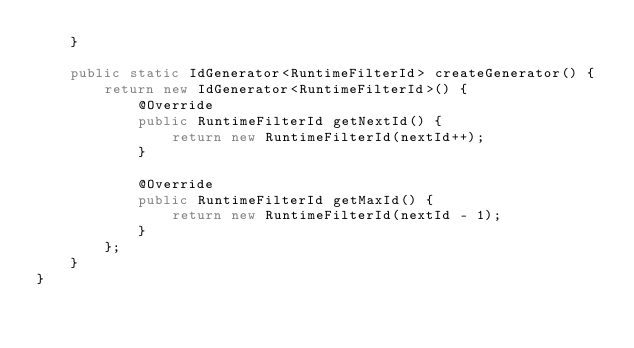<code> <loc_0><loc_0><loc_500><loc_500><_Java_>    }

    public static IdGenerator<RuntimeFilterId> createGenerator() {
        return new IdGenerator<RuntimeFilterId>() {
            @Override
            public RuntimeFilterId getNextId() {
                return new RuntimeFilterId(nextId++);
            }

            @Override
            public RuntimeFilterId getMaxId() {
                return new RuntimeFilterId(nextId - 1);
            }
        };
    }
}
</code> 